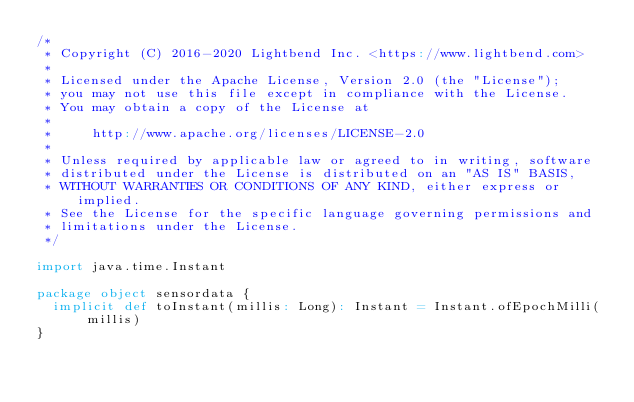Convert code to text. <code><loc_0><loc_0><loc_500><loc_500><_Scala_>/*
 * Copyright (C) 2016-2020 Lightbend Inc. <https://www.lightbend.com>
 *
 * Licensed under the Apache License, Version 2.0 (the "License");
 * you may not use this file except in compliance with the License.
 * You may obtain a copy of the License at
 *
 *     http://www.apache.org/licenses/LICENSE-2.0
 *
 * Unless required by applicable law or agreed to in writing, software
 * distributed under the License is distributed on an "AS IS" BASIS,
 * WITHOUT WARRANTIES OR CONDITIONS OF ANY KIND, either express or implied.
 * See the License for the specific language governing permissions and
 * limitations under the License.
 */

import java.time.Instant

package object sensordata {
  implicit def toInstant(millis: Long): Instant = Instant.ofEpochMilli(millis)
}

</code> 